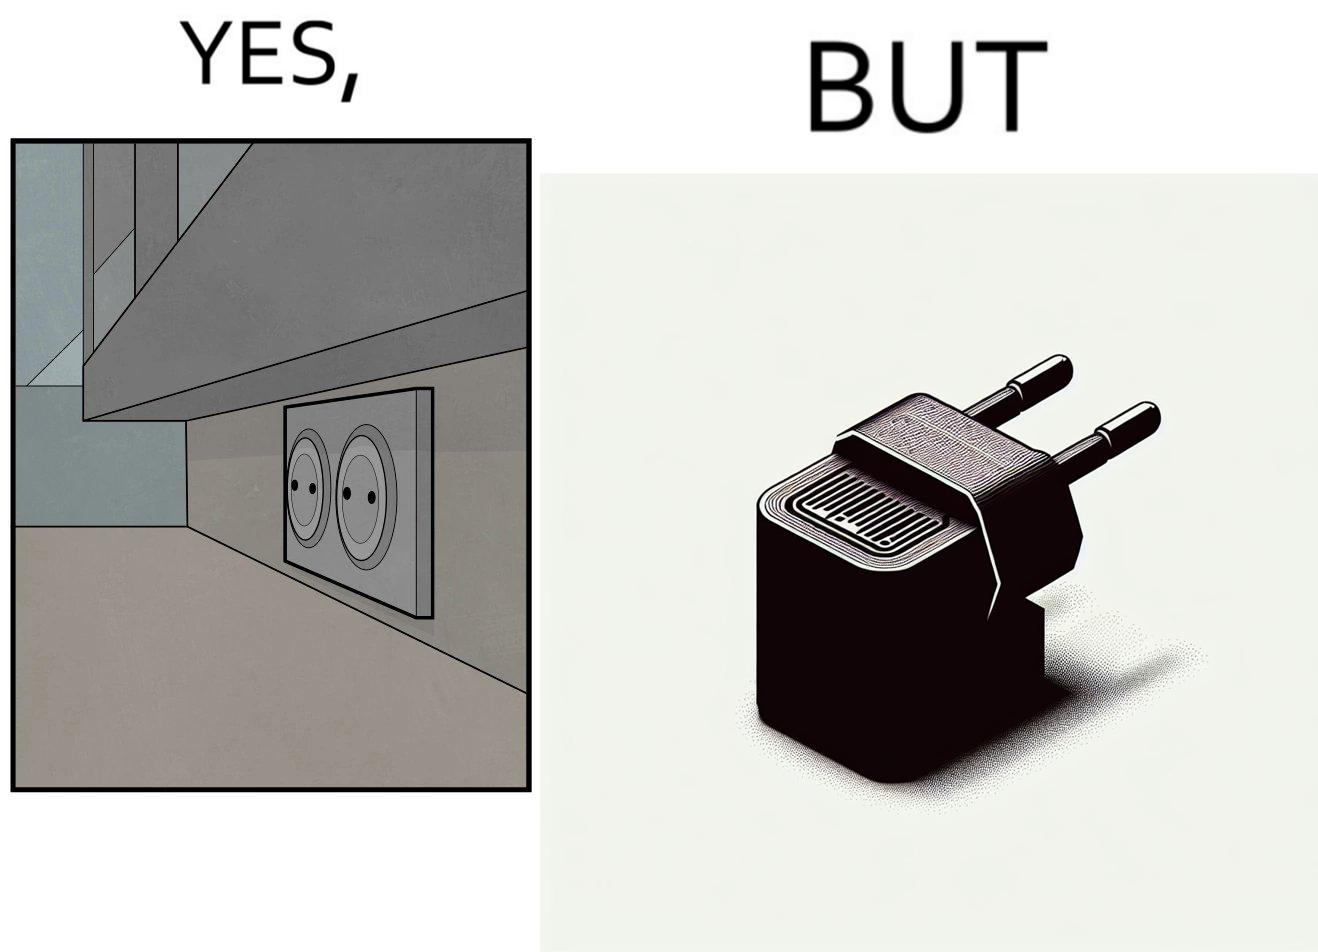Describe what you see in the left and right parts of this image. In the left part of the image: two electrical sockets side by side In the right part of the image: an electrical adapter 